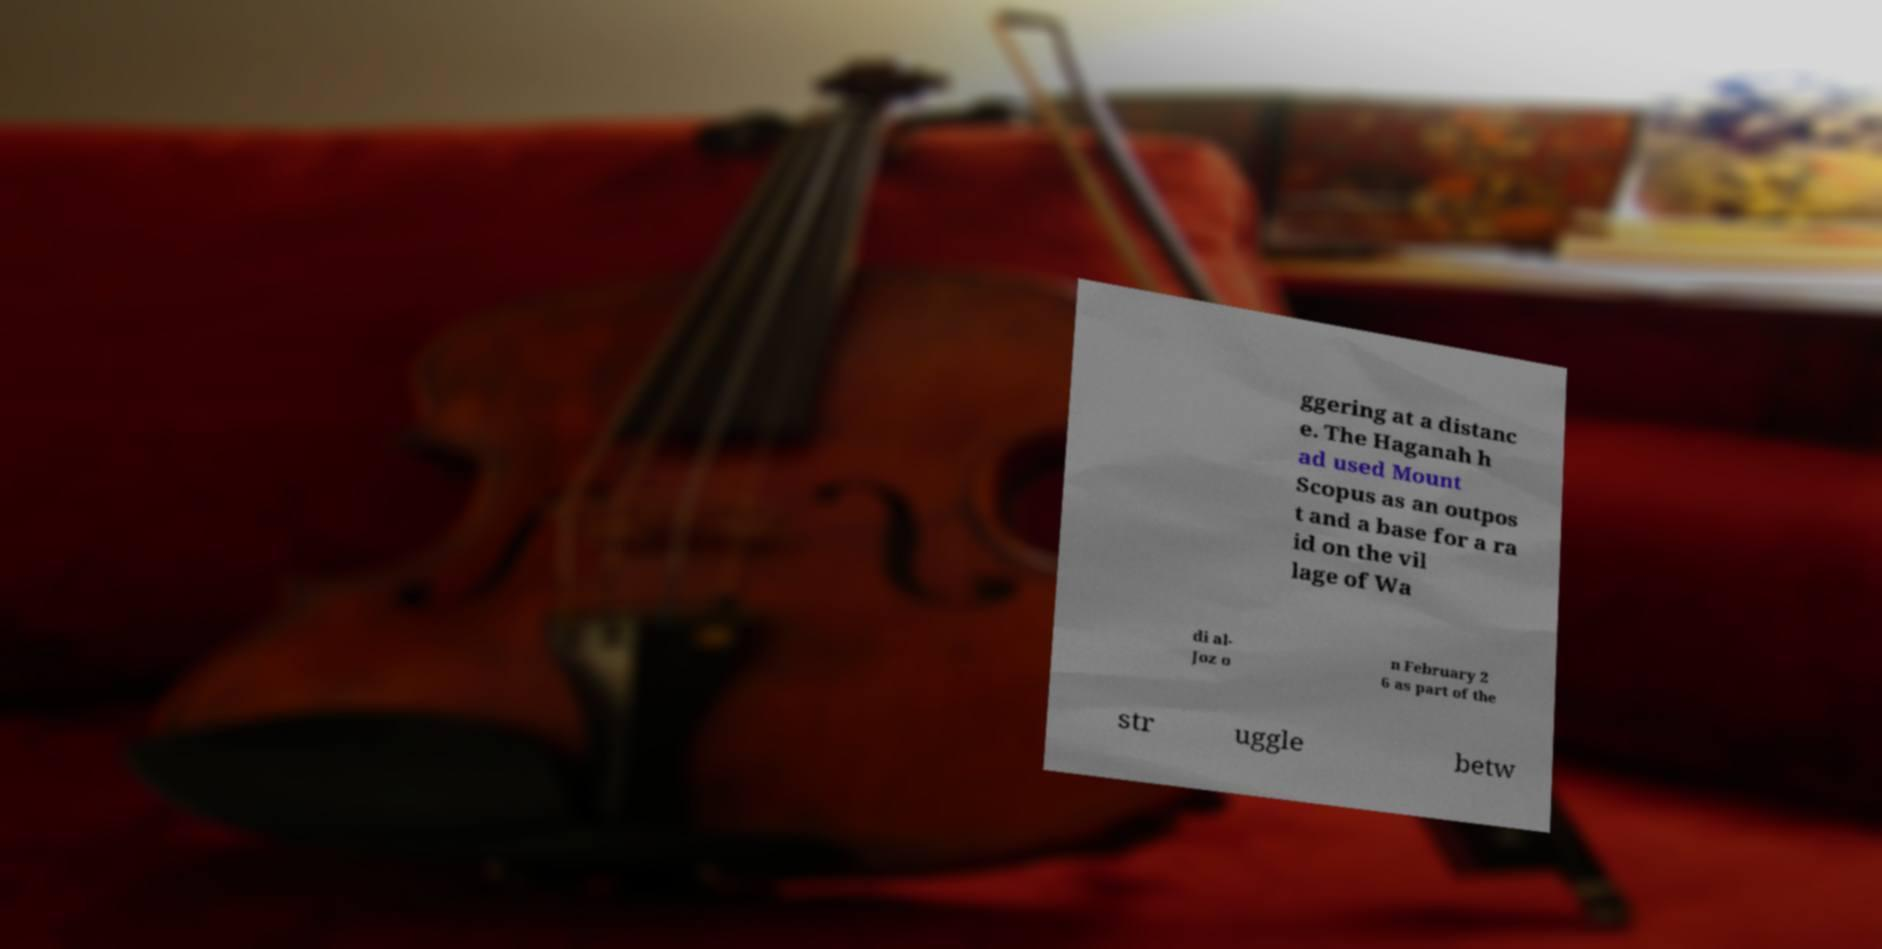Please read and relay the text visible in this image. What does it say? ggering at a distanc e. The Haganah h ad used Mount Scopus as an outpos t and a base for a ra id on the vil lage of Wa di al- Joz o n February 2 6 as part of the str uggle betw 